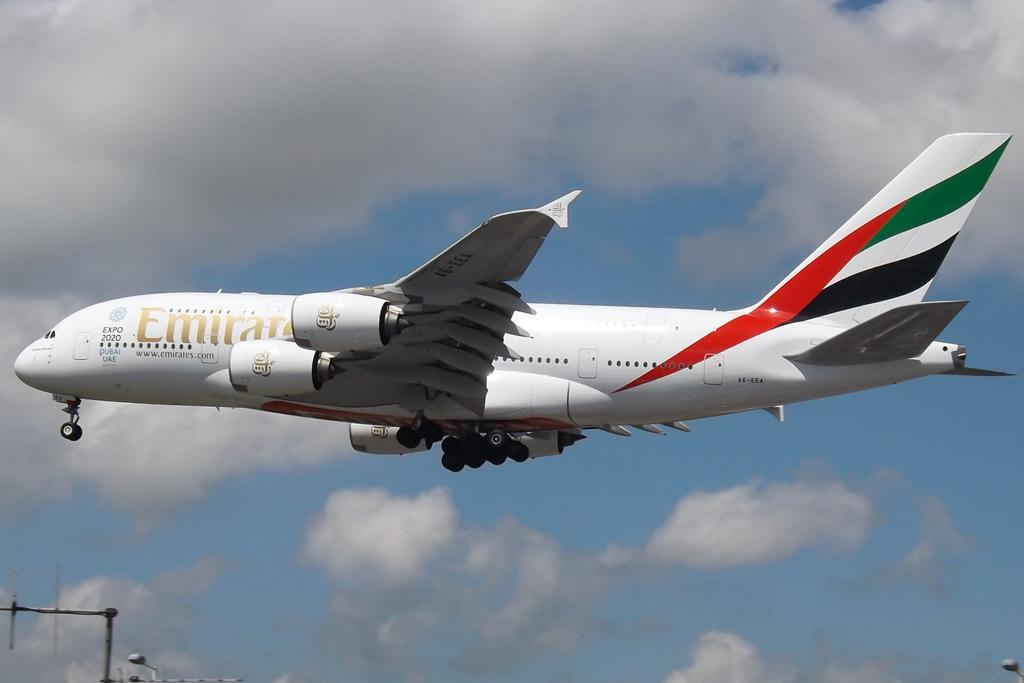<image>
Create a compact narrative representing the image presented. A passenger plane in flight has the website www.emirates.com listed under the name badge. 